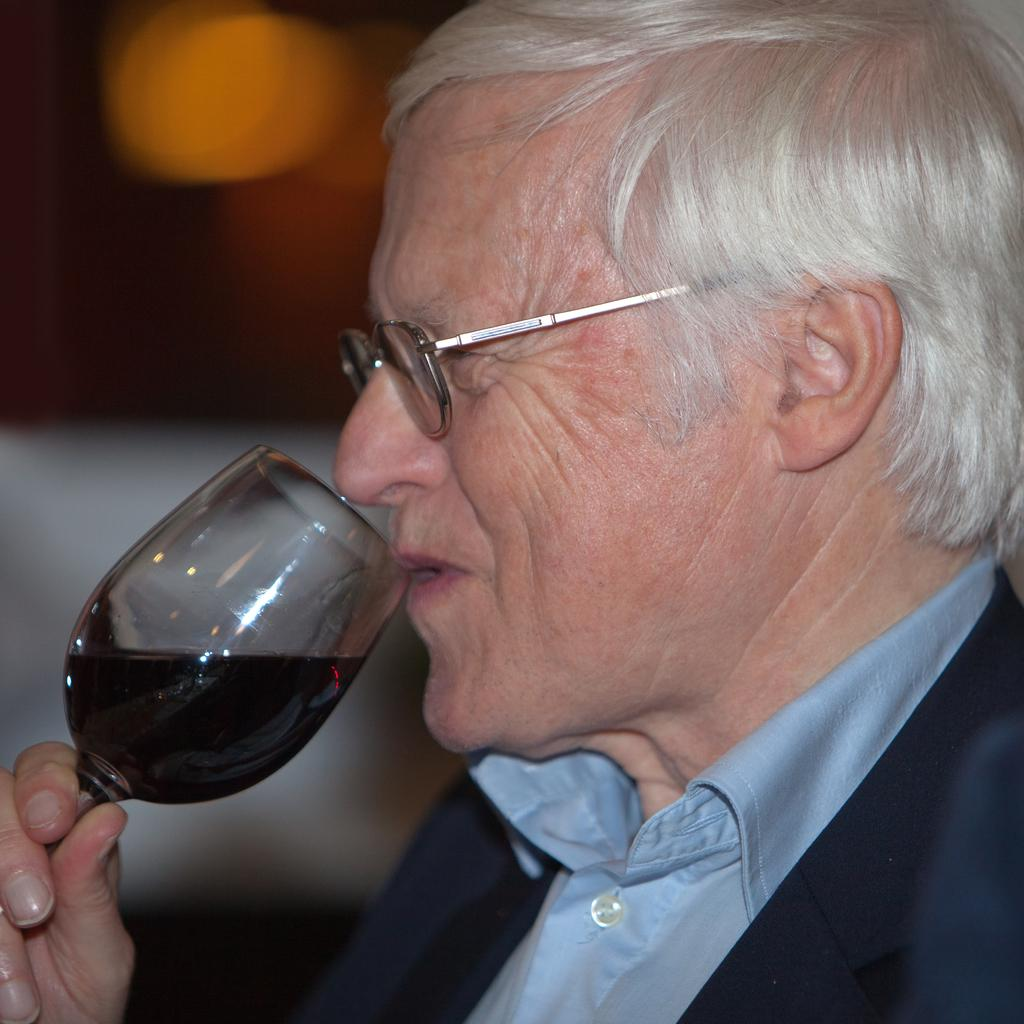What is present in the image? There is a man in the image. What is the man doing in the image? The man is drinking from a glass. What is inside the glass that the man is drinking from? The glass contains a drink. How many rings is the man wearing on his fingers in the image? There is no information about rings in the image; it only mentions the man drinking from a glass. What type of pen is the man holding in the image? There is no pen present in the image. 